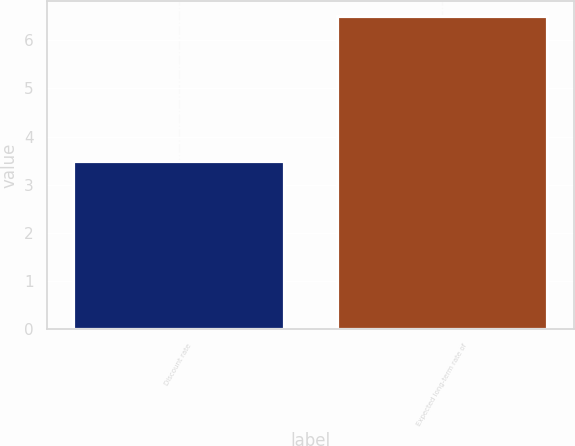<chart> <loc_0><loc_0><loc_500><loc_500><bar_chart><fcel>Discount rate<fcel>Expected long-term rate of<nl><fcel>3.49<fcel>6.5<nl></chart> 